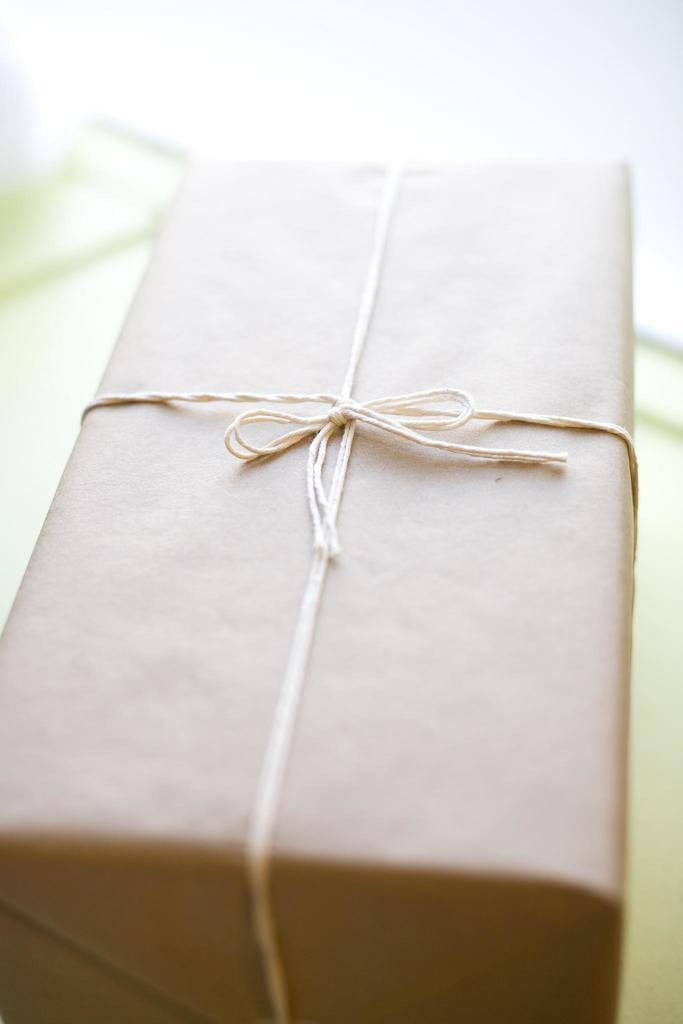What object is present in the image? There is a box in the image. How is the box secured or fastened? The box is tied with a thread. Can you describe the background of the image? The background of the image is blurry. What type of discovery is being made in the image? There is no indication of a discovery being made in the image; it only features a box tied with a thread against a blurry background. 